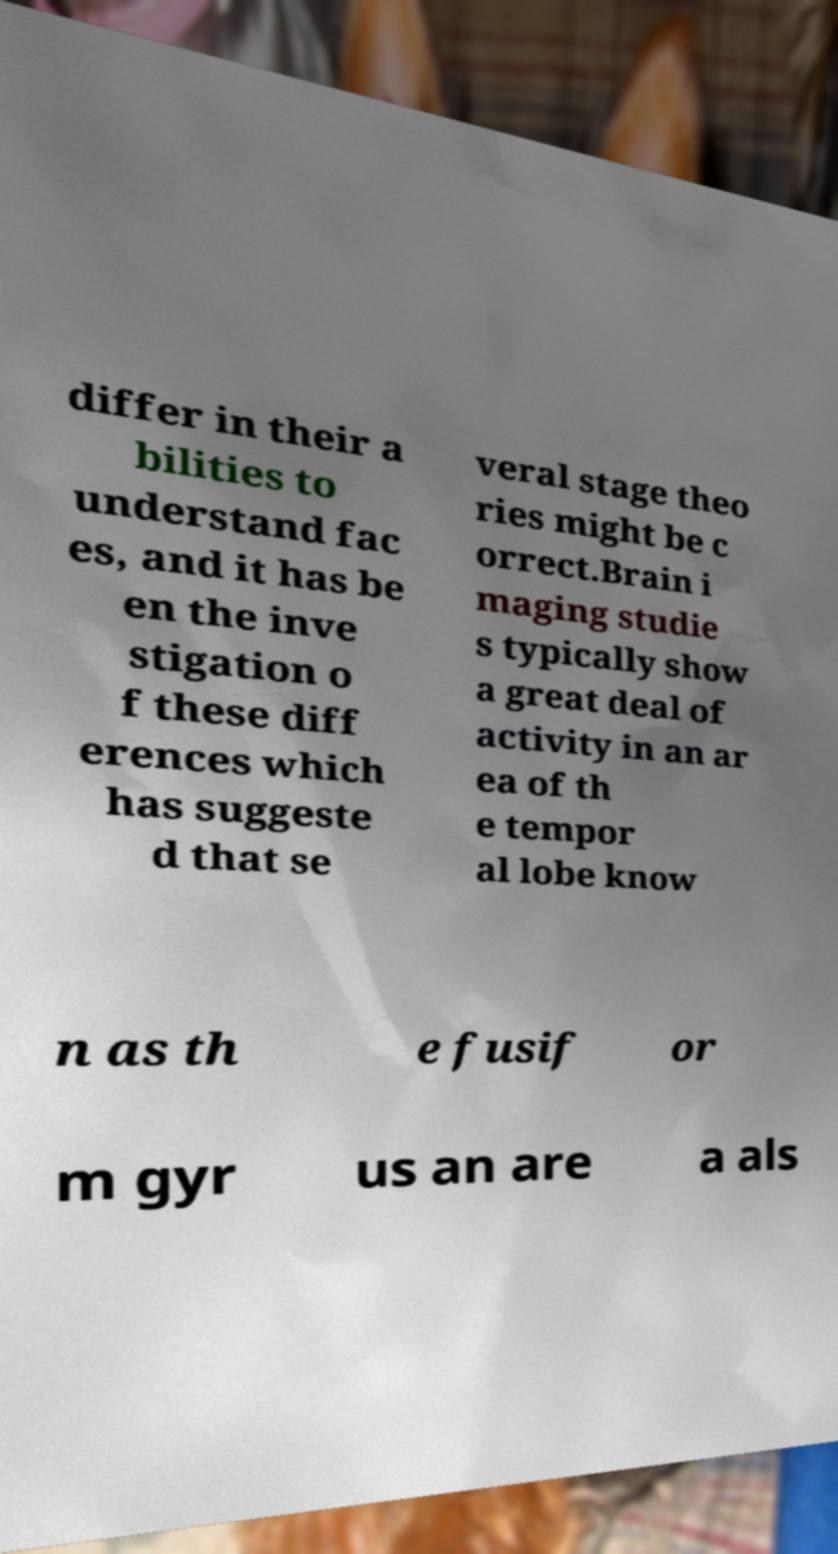Please read and relay the text visible in this image. What does it say? differ in their a bilities to understand fac es, and it has be en the inve stigation o f these diff erences which has suggeste d that se veral stage theo ries might be c orrect.Brain i maging studie s typically show a great deal of activity in an ar ea of th e tempor al lobe know n as th e fusif or m gyr us an are a als 